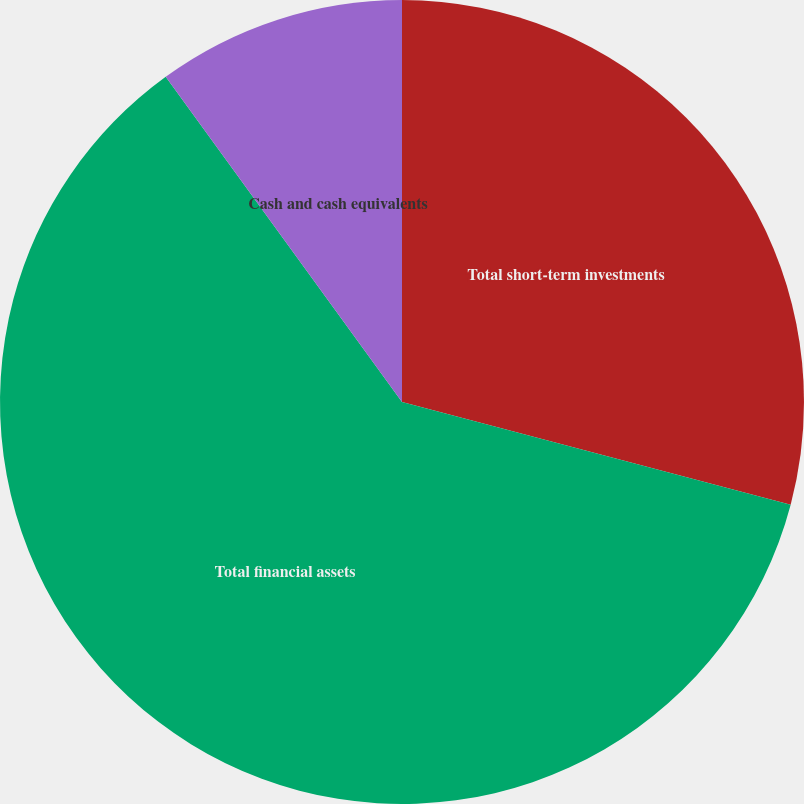Convert chart to OTSL. <chart><loc_0><loc_0><loc_500><loc_500><pie_chart><fcel>Total short-term investments<fcel>Total financial assets<fcel>Cash and cash equivalents<nl><fcel>29.11%<fcel>60.89%<fcel>10.0%<nl></chart> 